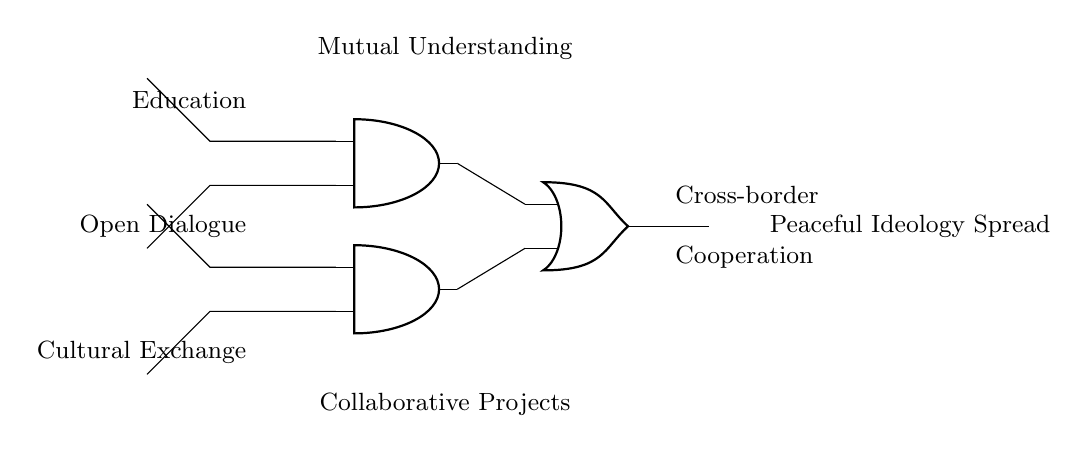What are the inputs to the circuit? The inputs are Education, Open Dialogue, and Cultural Exchange, which are shown at the left side of the circuit diagram.
Answer: Education, Open Dialogue, Cultural Exchange What types of gates are used in this circuit? The circuit uses AND gates and an OR gate. AND gates are depicted as two-input devices, while the OR gate is a single-output device that combines inputs.
Answer: AND gates and OR gate How many AND gates are present? There are two AND gates, indicated in the diagram, each performing a logical operation on their respective inputs.
Answer: 2 What is the output of the circuit? The output of the circuit is Peaceful Ideology Spread, which is indicated as the final result on the right side of the diagram.
Answer: Peaceful Ideology Spread What is required for the AND gates to output a signal? Both inputs to each AND gate must be high (true) for it to produce an output; this means that both mutual understanding and collaborative projects need to be emphasized.
Answer: Both inputs What does the OR gate represent in this circuit? The OR gate represents the idea that the spread of peaceful ideologies can occur through multiple pathways, either through mutual understanding or collaborative projects, enabling flexibility in the outputs.
Answer: Multiple pathways What is the significance of the labels near the AND gates? The labels near the AND gates indicate specific approaches or conditions (Mutual Understanding and Collaborative Projects) necessary for the inputs to contribute effectively to the spread of peaceful ideologies.
Answer: Specific approaches 